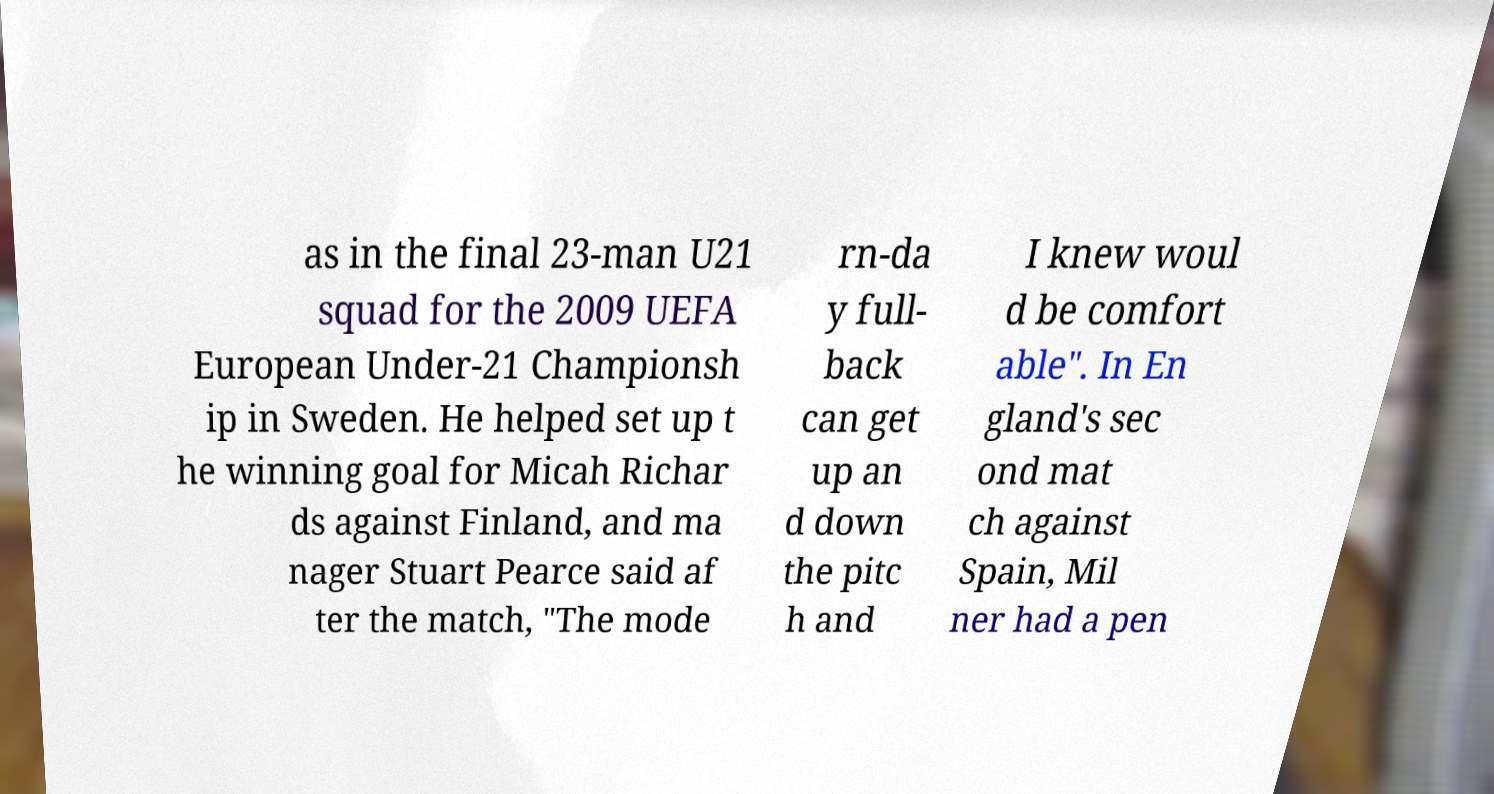I need the written content from this picture converted into text. Can you do that? as in the final 23-man U21 squad for the 2009 UEFA European Under-21 Championsh ip in Sweden. He helped set up t he winning goal for Micah Richar ds against Finland, and ma nager Stuart Pearce said af ter the match, "The mode rn-da y full- back can get up an d down the pitc h and I knew woul d be comfort able". In En gland's sec ond mat ch against Spain, Mil ner had a pen 